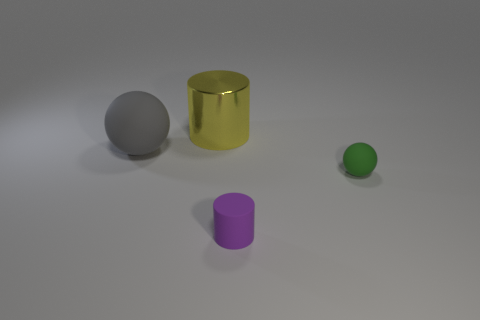There is another thing that is the same shape as the shiny object; what is its size?
Provide a succinct answer. Small. There is a cylinder that is behind the gray rubber sphere; how many small purple cylinders are to the right of it?
Make the answer very short. 1. There is a rubber ball that is on the right side of the yellow cylinder; is its size the same as the cylinder that is in front of the big cylinder?
Provide a short and direct response. Yes. How many tiny matte objects are there?
Your answer should be very brief. 2. How many purple objects are the same material as the purple cylinder?
Your answer should be very brief. 0. Are there an equal number of small purple rubber cylinders that are behind the small matte cylinder and yellow metal objects?
Make the answer very short. No. Does the green rubber ball have the same size as the cylinder that is in front of the yellow metal cylinder?
Keep it short and to the point. Yes. What number of other objects are the same size as the metal thing?
Provide a short and direct response. 1. What number of other objects are the same color as the big rubber ball?
Offer a terse response. 0. Do the green object and the purple matte cylinder have the same size?
Offer a very short reply. Yes. 